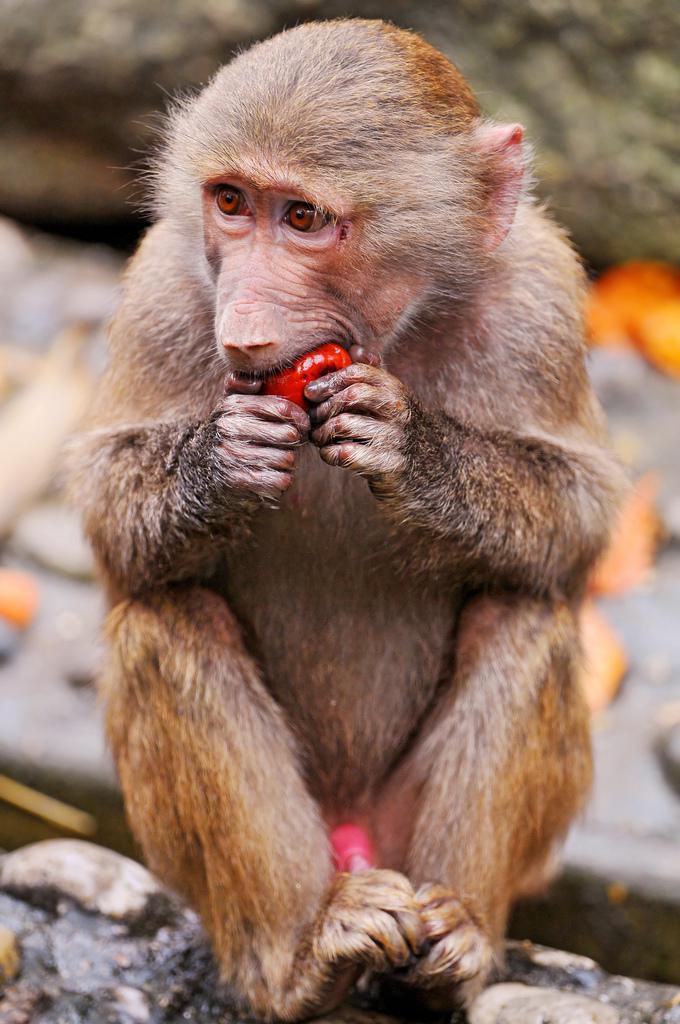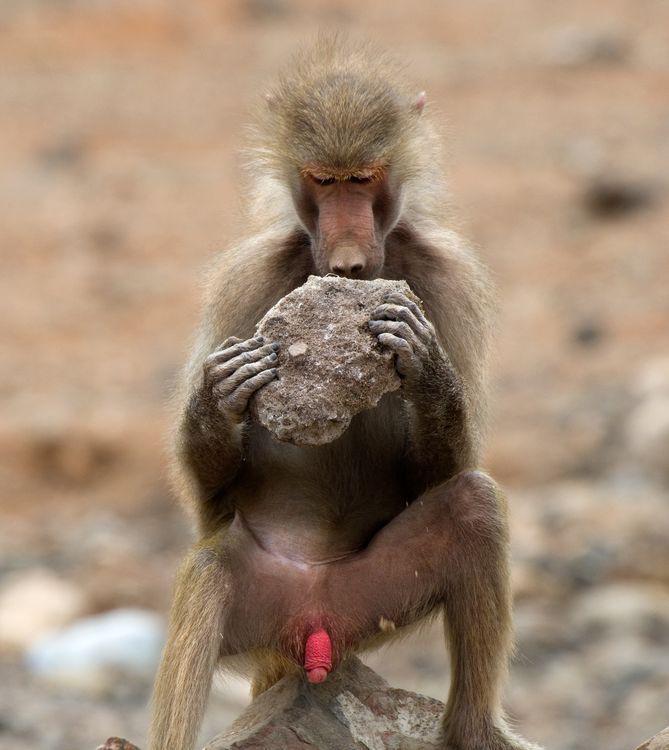The first image is the image on the left, the second image is the image on the right. Given the left and right images, does the statement "One image shows at least three baboons posed close together, and the other image shows one forward-facing baboon sitting with bent knees." hold true? Answer yes or no. No. The first image is the image on the left, the second image is the image on the right. Examine the images to the left and right. Is the description "The monkey in the right image is eating something." accurate? Answer yes or no. Yes. 